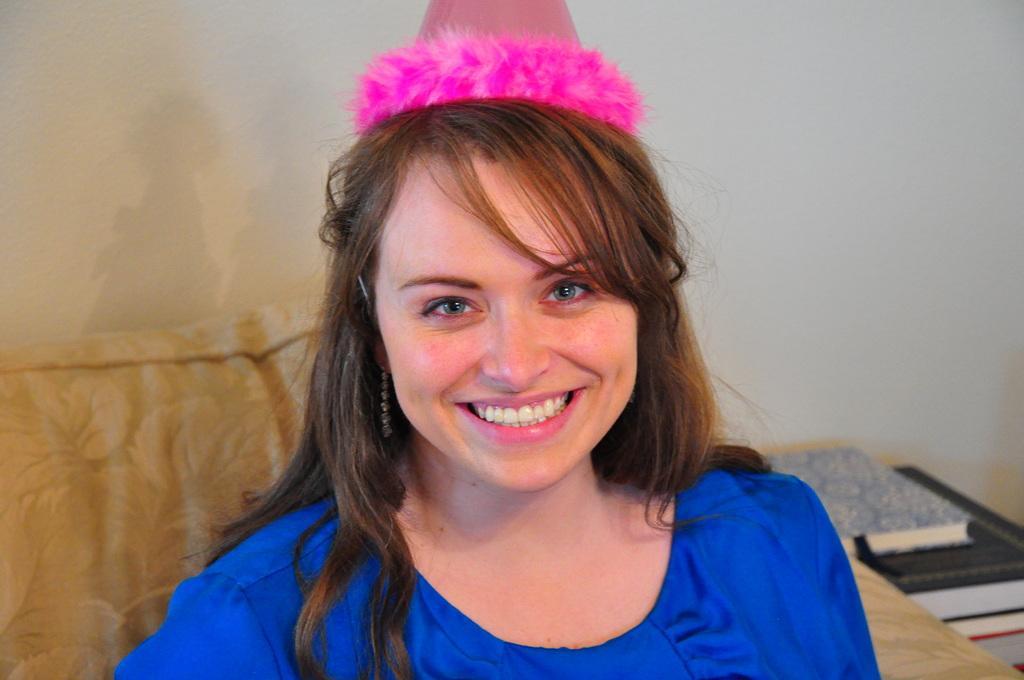Could you give a brief overview of what you see in this image? In this image I can see a person she wearing a blue color dress and she wearing a pink color cap on her head and she sit on the sofa beside her I can see a sofa on the right side. 